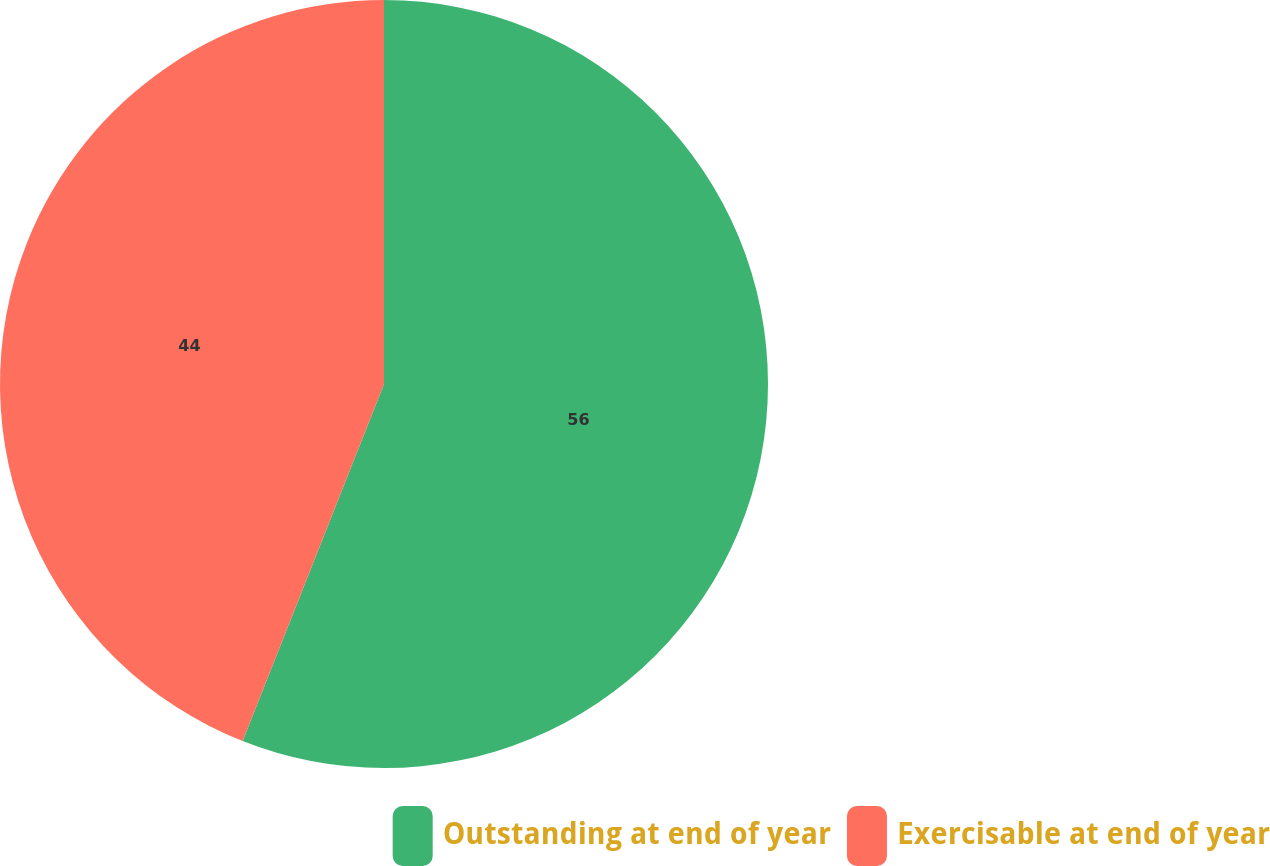Convert chart to OTSL. <chart><loc_0><loc_0><loc_500><loc_500><pie_chart><fcel>Outstanding at end of year<fcel>Exercisable at end of year<nl><fcel>56.0%<fcel>44.0%<nl></chart> 